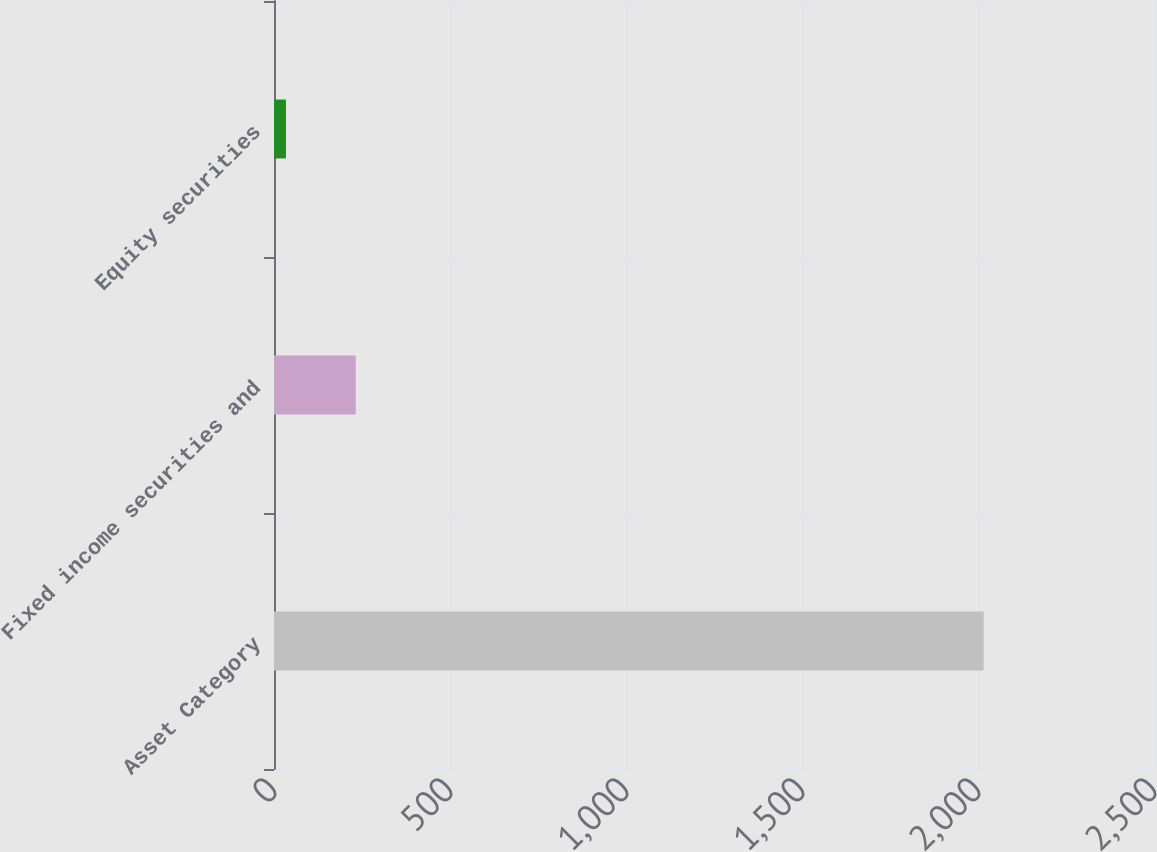Convert chart. <chart><loc_0><loc_0><loc_500><loc_500><bar_chart><fcel>Asset Category<fcel>Fixed income securities and<fcel>Equity securities<nl><fcel>2016<fcel>232.2<fcel>34<nl></chart> 